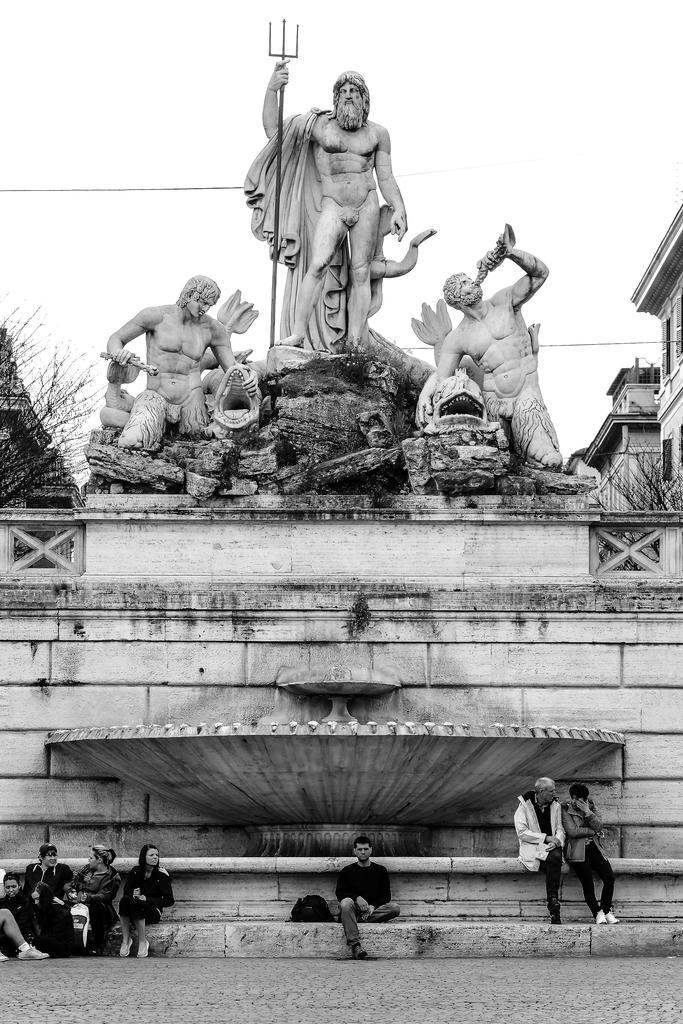In one or two sentences, can you explain what this image depicts? In this image we can see group of persons sitting on the ground. One person wearing white coat. In the background ,we can see several statues ,trees,group of buildings and sky. 